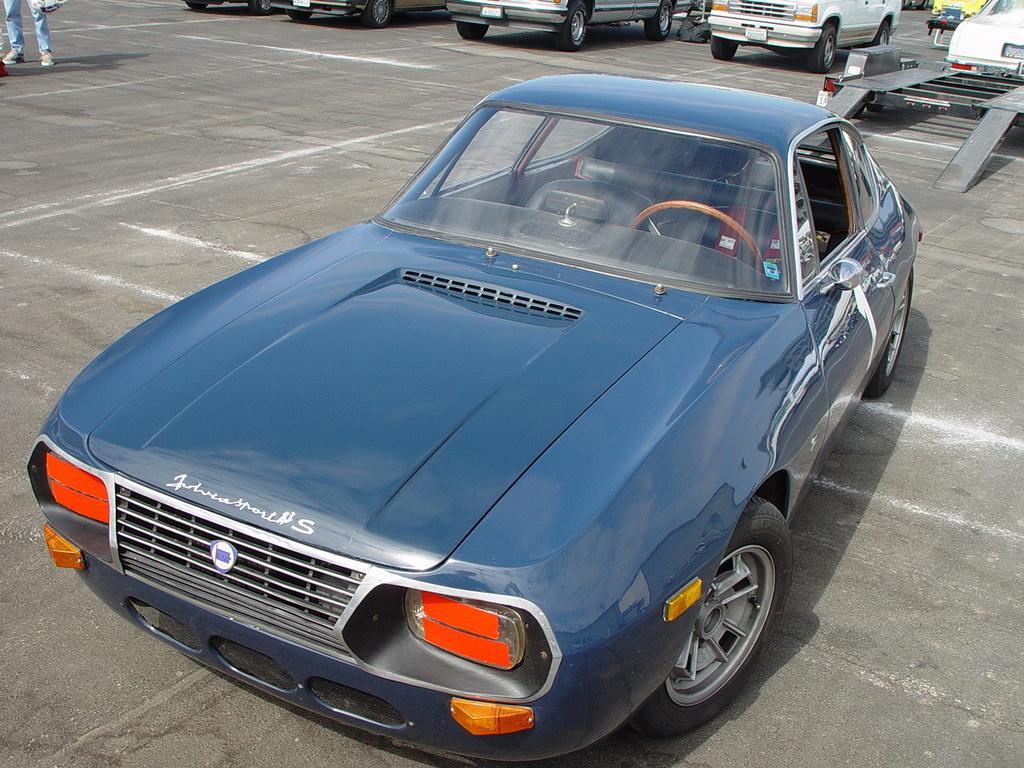Can you describe this image briefly? In this image there are vehicles parked on the road. On the left side of the image we can see the legs of a person. 